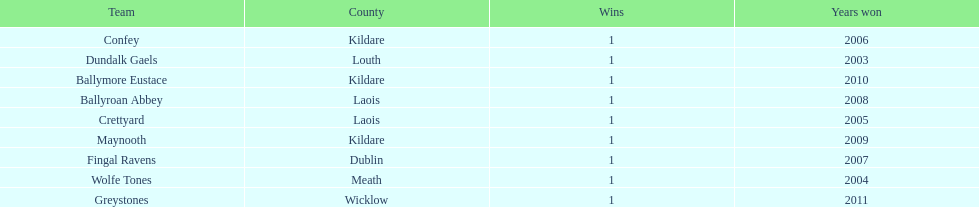Which team was the previous winner before ballyroan abbey in 2008? Fingal Ravens. 